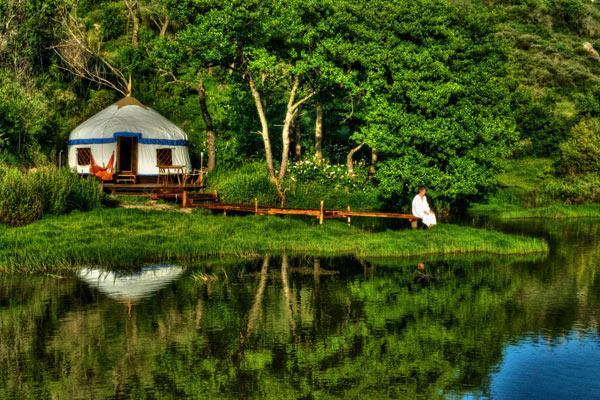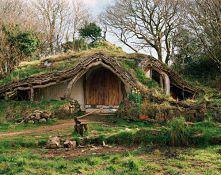The first image is the image on the left, the second image is the image on the right. Evaluate the accuracy of this statement regarding the images: "There is an ax in the image on the right.". Is it true? Answer yes or no. Yes. 